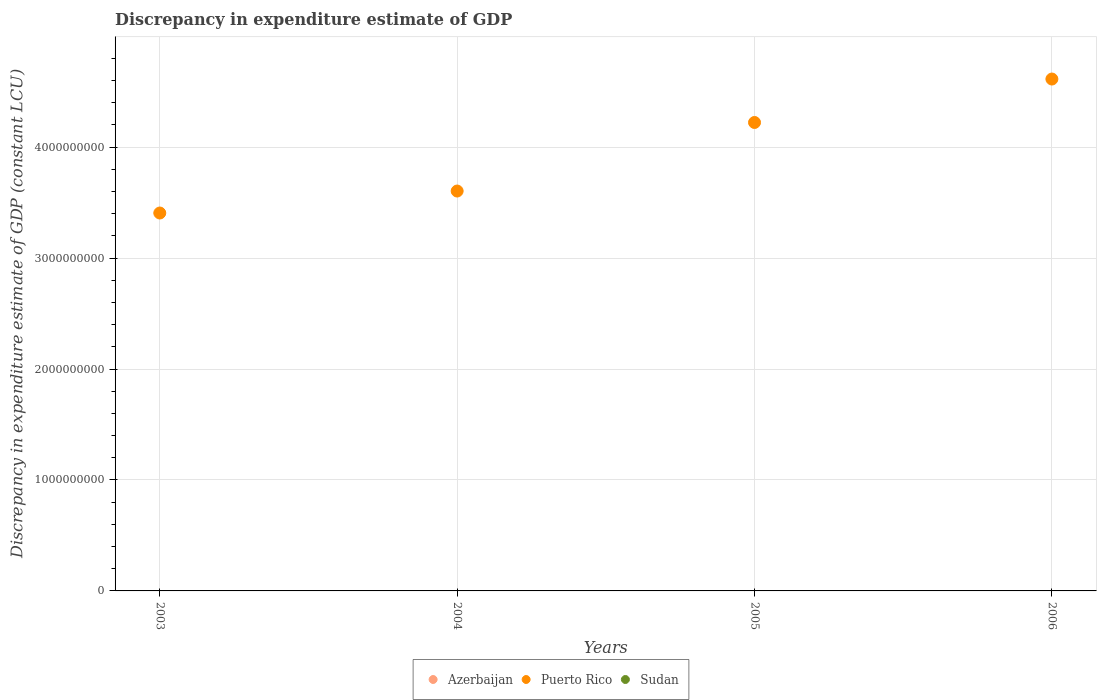What is the discrepancy in expenditure estimate of GDP in Azerbaijan in 2003?
Make the answer very short. 0. Across all years, what is the maximum discrepancy in expenditure estimate of GDP in Puerto Rico?
Your answer should be compact. 4.61e+09. Across all years, what is the minimum discrepancy in expenditure estimate of GDP in Azerbaijan?
Your response must be concise. 0. What is the total discrepancy in expenditure estimate of GDP in Puerto Rico in the graph?
Give a very brief answer. 1.58e+1. What is the difference between the discrepancy in expenditure estimate of GDP in Puerto Rico in 2003 and that in 2004?
Give a very brief answer. -1.98e+08. What is the difference between the discrepancy in expenditure estimate of GDP in Azerbaijan in 2006 and the discrepancy in expenditure estimate of GDP in Puerto Rico in 2003?
Your answer should be very brief. -3.41e+09. What is the ratio of the discrepancy in expenditure estimate of GDP in Puerto Rico in 2004 to that in 2006?
Keep it short and to the point. 0.78. Is the discrepancy in expenditure estimate of GDP in Puerto Rico in 2005 less than that in 2006?
Ensure brevity in your answer.  Yes. What is the difference between the highest and the second highest discrepancy in expenditure estimate of GDP in Puerto Rico?
Offer a terse response. 3.92e+08. What is the difference between the highest and the lowest discrepancy in expenditure estimate of GDP in Puerto Rico?
Provide a short and direct response. 1.21e+09. In how many years, is the discrepancy in expenditure estimate of GDP in Azerbaijan greater than the average discrepancy in expenditure estimate of GDP in Azerbaijan taken over all years?
Ensure brevity in your answer.  0. Is the discrepancy in expenditure estimate of GDP in Azerbaijan strictly greater than the discrepancy in expenditure estimate of GDP in Puerto Rico over the years?
Your answer should be compact. No. Are the values on the major ticks of Y-axis written in scientific E-notation?
Ensure brevity in your answer.  No. Does the graph contain any zero values?
Ensure brevity in your answer.  Yes. Where does the legend appear in the graph?
Offer a very short reply. Bottom center. How are the legend labels stacked?
Make the answer very short. Horizontal. What is the title of the graph?
Offer a terse response. Discrepancy in expenditure estimate of GDP. Does "Zimbabwe" appear as one of the legend labels in the graph?
Provide a succinct answer. No. What is the label or title of the X-axis?
Your answer should be compact. Years. What is the label or title of the Y-axis?
Offer a terse response. Discrepancy in expenditure estimate of GDP (constant LCU). What is the Discrepancy in expenditure estimate of GDP (constant LCU) of Puerto Rico in 2003?
Offer a terse response. 3.41e+09. What is the Discrepancy in expenditure estimate of GDP (constant LCU) in Sudan in 2003?
Provide a short and direct response. 0. What is the Discrepancy in expenditure estimate of GDP (constant LCU) in Puerto Rico in 2004?
Ensure brevity in your answer.  3.60e+09. What is the Discrepancy in expenditure estimate of GDP (constant LCU) of Azerbaijan in 2005?
Offer a very short reply. 0. What is the Discrepancy in expenditure estimate of GDP (constant LCU) of Puerto Rico in 2005?
Give a very brief answer. 4.22e+09. What is the Discrepancy in expenditure estimate of GDP (constant LCU) of Puerto Rico in 2006?
Provide a succinct answer. 4.61e+09. Across all years, what is the maximum Discrepancy in expenditure estimate of GDP (constant LCU) of Puerto Rico?
Give a very brief answer. 4.61e+09. Across all years, what is the minimum Discrepancy in expenditure estimate of GDP (constant LCU) in Puerto Rico?
Make the answer very short. 3.41e+09. What is the total Discrepancy in expenditure estimate of GDP (constant LCU) of Azerbaijan in the graph?
Keep it short and to the point. 0. What is the total Discrepancy in expenditure estimate of GDP (constant LCU) of Puerto Rico in the graph?
Provide a short and direct response. 1.58e+1. What is the total Discrepancy in expenditure estimate of GDP (constant LCU) of Sudan in the graph?
Give a very brief answer. 0. What is the difference between the Discrepancy in expenditure estimate of GDP (constant LCU) in Puerto Rico in 2003 and that in 2004?
Your answer should be very brief. -1.98e+08. What is the difference between the Discrepancy in expenditure estimate of GDP (constant LCU) in Puerto Rico in 2003 and that in 2005?
Give a very brief answer. -8.16e+08. What is the difference between the Discrepancy in expenditure estimate of GDP (constant LCU) of Puerto Rico in 2003 and that in 2006?
Offer a very short reply. -1.21e+09. What is the difference between the Discrepancy in expenditure estimate of GDP (constant LCU) in Puerto Rico in 2004 and that in 2005?
Your response must be concise. -6.18e+08. What is the difference between the Discrepancy in expenditure estimate of GDP (constant LCU) in Puerto Rico in 2004 and that in 2006?
Your answer should be very brief. -1.01e+09. What is the difference between the Discrepancy in expenditure estimate of GDP (constant LCU) of Puerto Rico in 2005 and that in 2006?
Make the answer very short. -3.92e+08. What is the average Discrepancy in expenditure estimate of GDP (constant LCU) in Azerbaijan per year?
Provide a succinct answer. 0. What is the average Discrepancy in expenditure estimate of GDP (constant LCU) of Puerto Rico per year?
Provide a succinct answer. 3.96e+09. What is the average Discrepancy in expenditure estimate of GDP (constant LCU) of Sudan per year?
Provide a succinct answer. 0. What is the ratio of the Discrepancy in expenditure estimate of GDP (constant LCU) of Puerto Rico in 2003 to that in 2004?
Ensure brevity in your answer.  0.94. What is the ratio of the Discrepancy in expenditure estimate of GDP (constant LCU) in Puerto Rico in 2003 to that in 2005?
Offer a very short reply. 0.81. What is the ratio of the Discrepancy in expenditure estimate of GDP (constant LCU) of Puerto Rico in 2003 to that in 2006?
Your answer should be very brief. 0.74. What is the ratio of the Discrepancy in expenditure estimate of GDP (constant LCU) in Puerto Rico in 2004 to that in 2005?
Offer a very short reply. 0.85. What is the ratio of the Discrepancy in expenditure estimate of GDP (constant LCU) in Puerto Rico in 2004 to that in 2006?
Your answer should be compact. 0.78. What is the ratio of the Discrepancy in expenditure estimate of GDP (constant LCU) of Puerto Rico in 2005 to that in 2006?
Ensure brevity in your answer.  0.92. What is the difference between the highest and the second highest Discrepancy in expenditure estimate of GDP (constant LCU) in Puerto Rico?
Your answer should be compact. 3.92e+08. What is the difference between the highest and the lowest Discrepancy in expenditure estimate of GDP (constant LCU) in Puerto Rico?
Make the answer very short. 1.21e+09. 